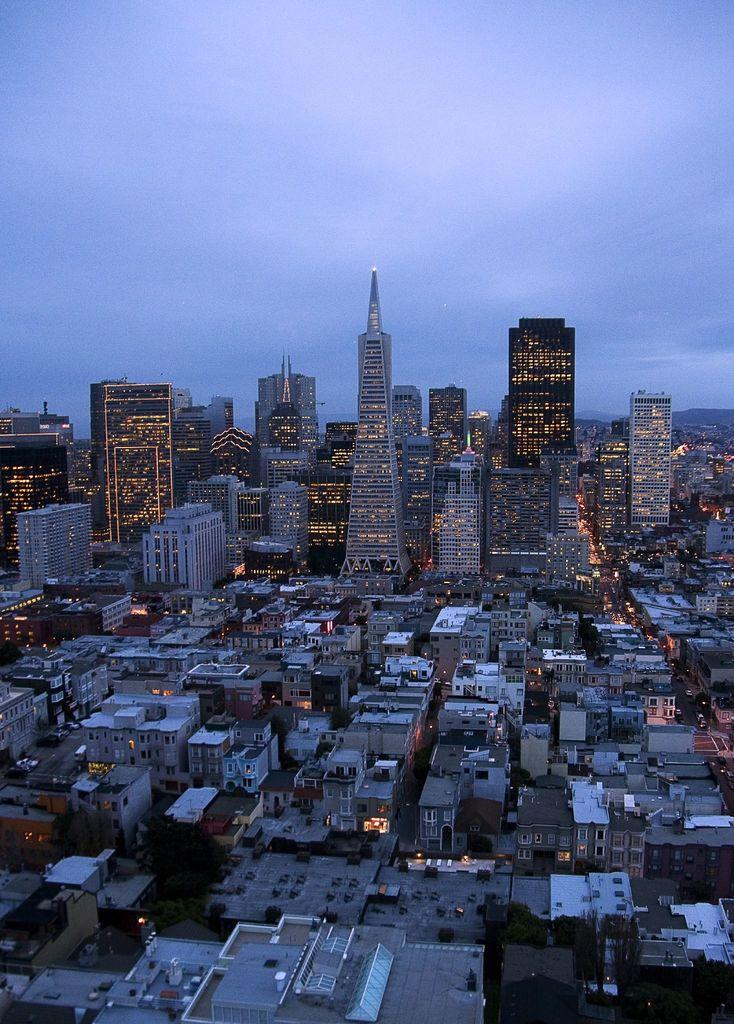What type of view is depicted in the image? The image is an aerial view. What structures can be seen in the image? There are buildings in the image. What can be seen illuminating the scene in the image? Lights are visible in the image. What feature is present on top of the buildings in the image? Roofs are present in the image. What type of vegetation is visible in the image? Trees are visible in the image. What type of transportation infrastructure is present in the image? Roads are present in the image. What type of vehicles can be seen on the roads in the image? Vehicles are visible in the image. What is visible in the sky at the top of the image? Clouds are present in the sky at the top of the image. How many toes are visible on the buildings in the image? There are no toes present in the image, as it is a view of a cityscape and not a person's feet. 